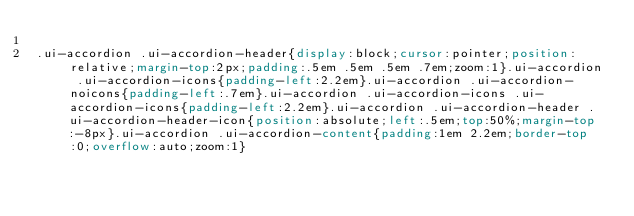<code> <loc_0><loc_0><loc_500><loc_500><_CSS_>
.ui-accordion .ui-accordion-header{display:block;cursor:pointer;position:relative;margin-top:2px;padding:.5em .5em .5em .7em;zoom:1}.ui-accordion .ui-accordion-icons{padding-left:2.2em}.ui-accordion .ui-accordion-noicons{padding-left:.7em}.ui-accordion .ui-accordion-icons .ui-accordion-icons{padding-left:2.2em}.ui-accordion .ui-accordion-header .ui-accordion-header-icon{position:absolute;left:.5em;top:50%;margin-top:-8px}.ui-accordion .ui-accordion-content{padding:1em 2.2em;border-top:0;overflow:auto;zoom:1}</code> 